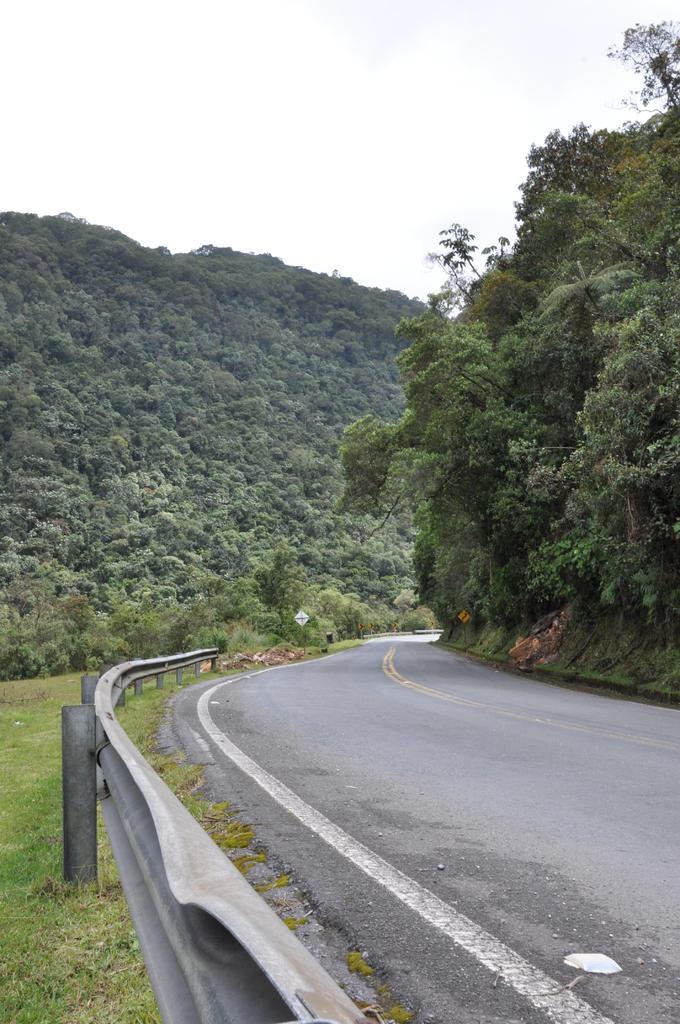Could you give a brief overview of what you see in this image? At the bottom of the image there is road and fencing and grass. In the middle of the image there is a sign board and trees and hills. At the bottom of the image there is sky. 